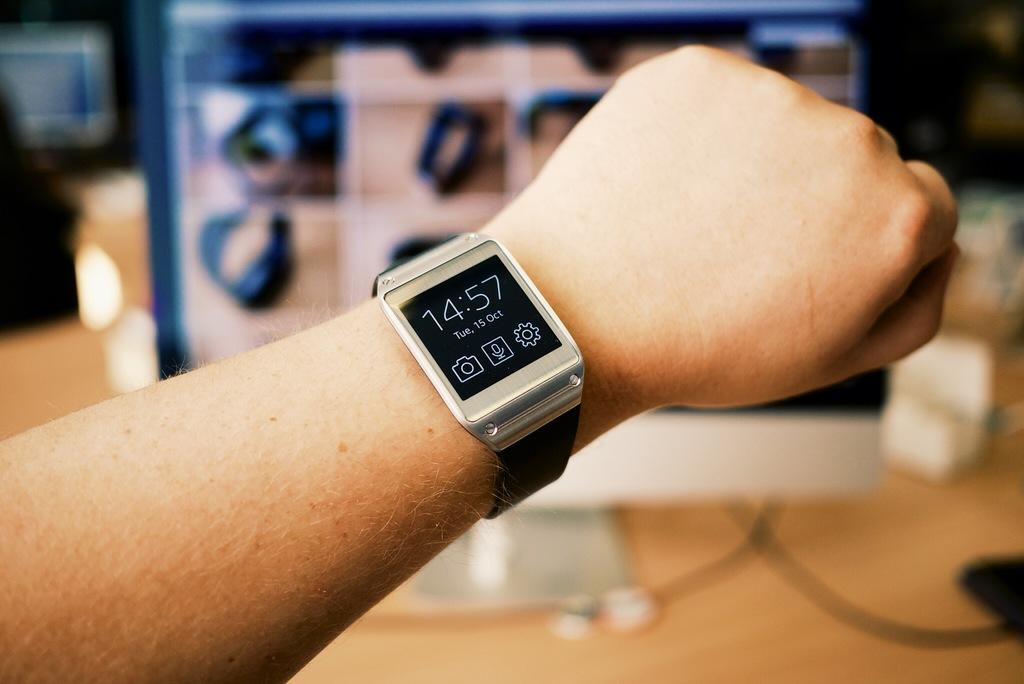Provide a one-sentence caption for the provided image. A watch shown on a person's wrist showing the time 14:57 and the date Tue, 15 Oct. 